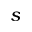<formula> <loc_0><loc_0><loc_500><loc_500>s</formula> 